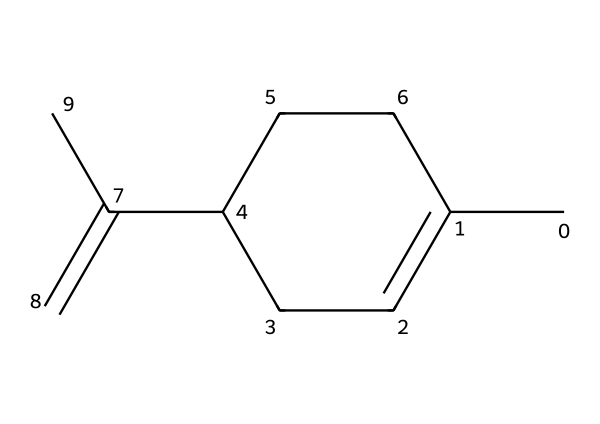What is the molecular formula of this compound? To determine the molecular formula, we count the number of each type of atom in the structure. The SMILES representation indicates there are 10 carbon (C) atoms and 14 hydrogen (H) atoms. Therefore, the molecular formula is C10H14.
Answer: C10H14 How many double bonds are present in the structure? By analyzing the structure, we see there is one double bond in the chemical structure, specifically at the C(=C) site.
Answer: 1 What type of chemical structure is this compound classified as? The presence of multiple carbon atoms arranged in a ring with aliphatic characteristics indicates this compound is a terpene, specifically a monocyclic terpene due to the cyclic structure.
Answer: terpene What is the total number of rings in this chemical structure? In the provided SMILES, there is one ring formed by the CC1=CCC(…) structure, which is indicated by the use of the digit ‘1’ denoting the start and end of the ring.
Answer: 1 Is this compound likely to be solid or liquid at room temperature? Given that this is a terpene, which typically has lower molecular weights and may remain liquid at room temperature, it is more likely to be a liquid than a solid.
Answer: liquid Which carbon in the structure is part of a double bond? By evaluating the provided structure, the carbon atom involved in the double bond is indicated in the part C(=C). Therefore, the second carbon in the sequence is the one that participates in the double bond.
Answer: second carbon 